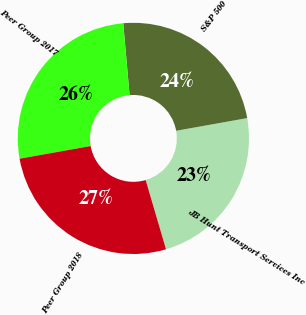Convert chart to OTSL. <chart><loc_0><loc_0><loc_500><loc_500><pie_chart><fcel>JB Hunt Transport Services Inc<fcel>S&P 500<fcel>Peer Group 2017<fcel>Peer Group 2018<nl><fcel>23.26%<fcel>23.59%<fcel>26.41%<fcel>26.74%<nl></chart> 